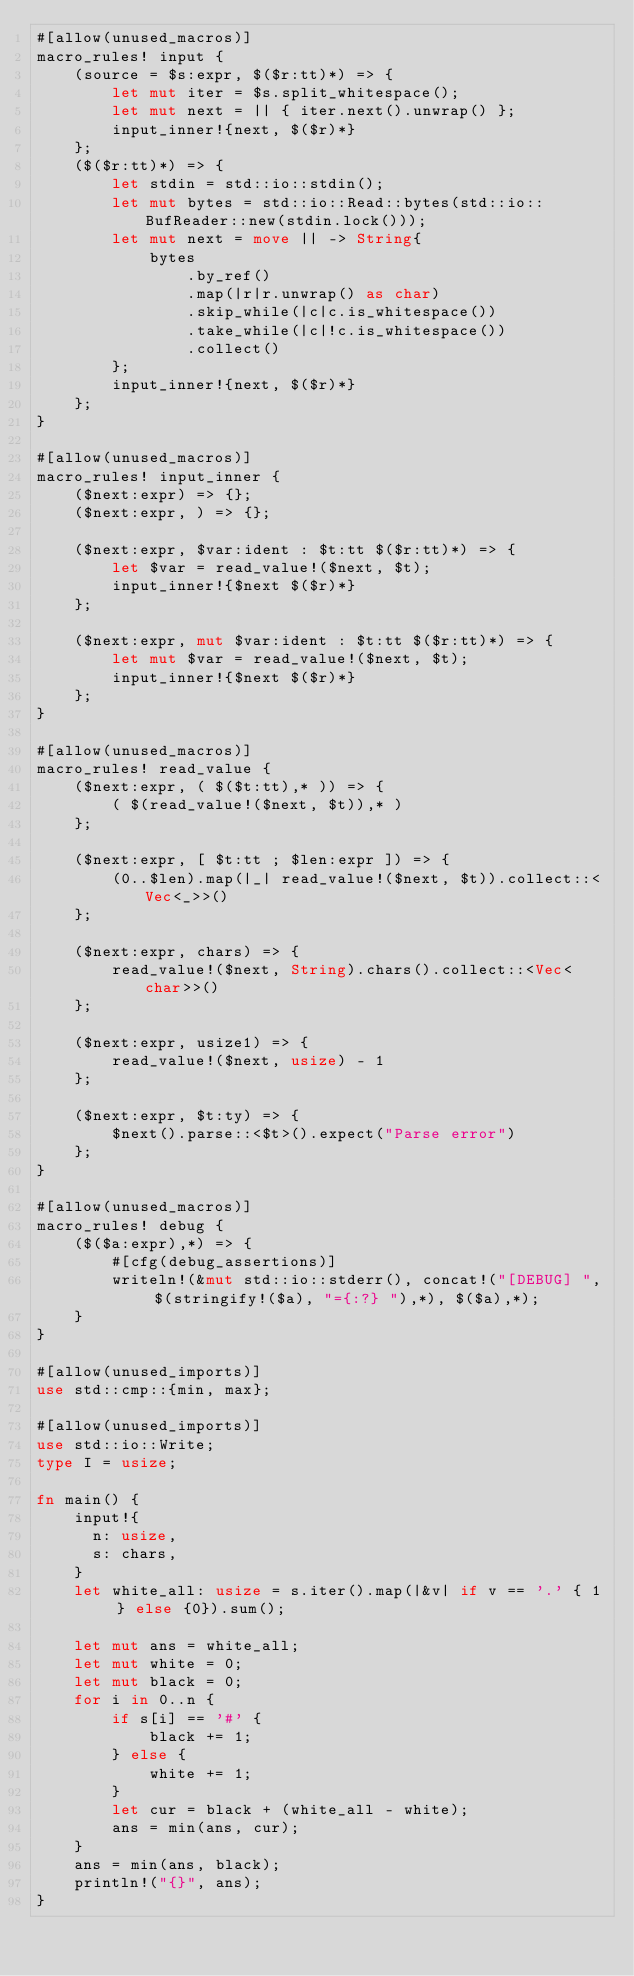Convert code to text. <code><loc_0><loc_0><loc_500><loc_500><_Rust_>#[allow(unused_macros)]
macro_rules! input {
    (source = $s:expr, $($r:tt)*) => {
        let mut iter = $s.split_whitespace();
        let mut next = || { iter.next().unwrap() };
        input_inner!{next, $($r)*}
    };
    ($($r:tt)*) => {
        let stdin = std::io::stdin();
        let mut bytes = std::io::Read::bytes(std::io::BufReader::new(stdin.lock()));
        let mut next = move || -> String{
            bytes
                .by_ref()
                .map(|r|r.unwrap() as char)
                .skip_while(|c|c.is_whitespace())
                .take_while(|c|!c.is_whitespace())
                .collect()
        };
        input_inner!{next, $($r)*}
    };
}

#[allow(unused_macros)]
macro_rules! input_inner {
    ($next:expr) => {};
    ($next:expr, ) => {};

    ($next:expr, $var:ident : $t:tt $($r:tt)*) => {
        let $var = read_value!($next, $t);
        input_inner!{$next $($r)*}
    };

    ($next:expr, mut $var:ident : $t:tt $($r:tt)*) => {
        let mut $var = read_value!($next, $t);
        input_inner!{$next $($r)*}
    };
}

#[allow(unused_macros)]
macro_rules! read_value {
    ($next:expr, ( $($t:tt),* )) => {
        ( $(read_value!($next, $t)),* )
    };

    ($next:expr, [ $t:tt ; $len:expr ]) => {
        (0..$len).map(|_| read_value!($next, $t)).collect::<Vec<_>>()
    };

    ($next:expr, chars) => {
        read_value!($next, String).chars().collect::<Vec<char>>()
    };

    ($next:expr, usize1) => {
        read_value!($next, usize) - 1
    };

    ($next:expr, $t:ty) => {
        $next().parse::<$t>().expect("Parse error")
    };
}

#[allow(unused_macros)]
macro_rules! debug {
    ($($a:expr),*) => {
        #[cfg(debug_assertions)]
        writeln!(&mut std::io::stderr(), concat!("[DEBUG] ", $(stringify!($a), "={:?} "),*), $($a),*);
    }
}

#[allow(unused_imports)]
use std::cmp::{min, max};

#[allow(unused_imports)]
use std::io::Write;
type I = usize;

fn main() {
    input!{
      n: usize,
      s: chars,
    }
    let white_all: usize = s.iter().map(|&v| if v == '.' { 1 } else {0}).sum();

    let mut ans = white_all;
    let mut white = 0;
    let mut black = 0;
    for i in 0..n {
        if s[i] == '#' {
            black += 1;
        } else {
            white += 1;
        }
        let cur = black + (white_all - white);
        ans = min(ans, cur);
    }
    ans = min(ans, black);
    println!("{}", ans);
}
</code> 